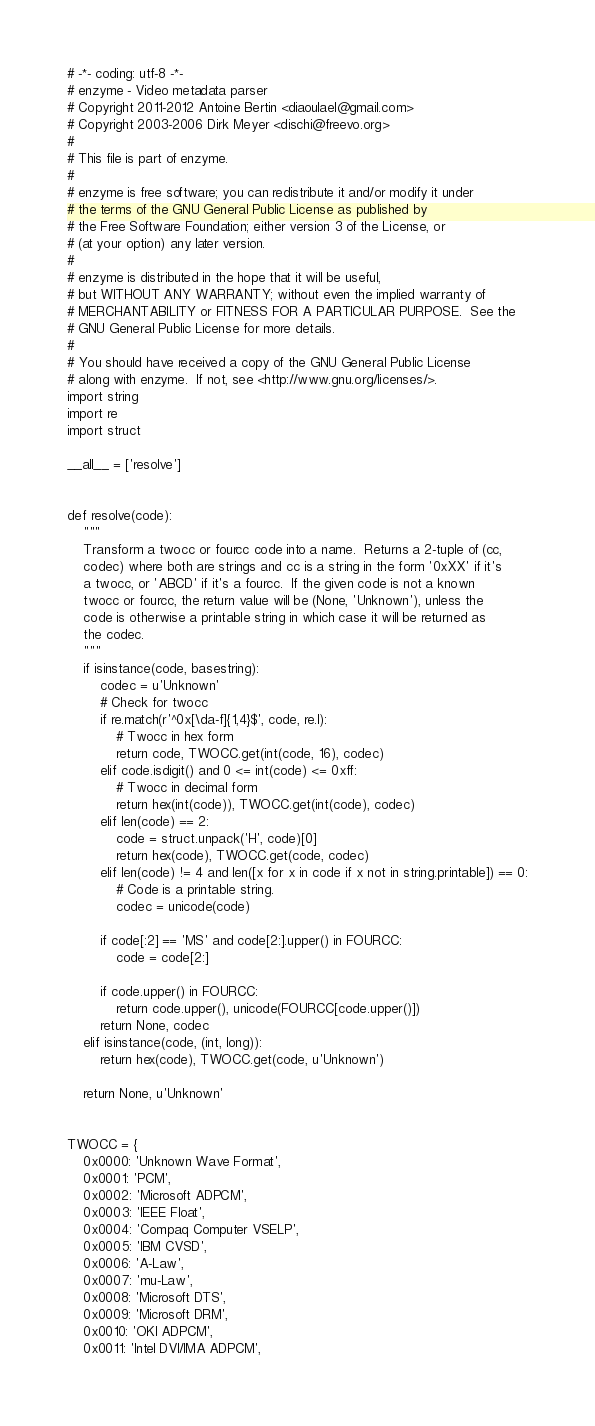<code> <loc_0><loc_0><loc_500><loc_500><_Python_># -*- coding: utf-8 -*-
# enzyme - Video metadata parser
# Copyright 2011-2012 Antoine Bertin <diaoulael@gmail.com>
# Copyright 2003-2006 Dirk Meyer <dischi@freevo.org>
#
# This file is part of enzyme.
#
# enzyme is free software; you can redistribute it and/or modify it under
# the terms of the GNU General Public License as published by
# the Free Software Foundation; either version 3 of the License, or
# (at your option) any later version.
#
# enzyme is distributed in the hope that it will be useful,
# but WITHOUT ANY WARRANTY; without even the implied warranty of
# MERCHANTABILITY or FITNESS FOR A PARTICULAR PURPOSE.  See the
# GNU General Public License for more details.
#
# You should have received a copy of the GNU General Public License
# along with enzyme.  If not, see <http://www.gnu.org/licenses/>.
import string
import re
import struct

__all__ = ['resolve']


def resolve(code):
    """
    Transform a twocc or fourcc code into a name.  Returns a 2-tuple of (cc,
    codec) where both are strings and cc is a string in the form '0xXX' if it's
    a twocc, or 'ABCD' if it's a fourcc.  If the given code is not a known
    twocc or fourcc, the return value will be (None, 'Unknown'), unless the
    code is otherwise a printable string in which case it will be returned as
    the codec.
    """
    if isinstance(code, basestring):
        codec = u'Unknown'
        # Check for twocc
        if re.match(r'^0x[\da-f]{1,4}$', code, re.I):
            # Twocc in hex form
            return code, TWOCC.get(int(code, 16), codec)
        elif code.isdigit() and 0 <= int(code) <= 0xff:
            # Twocc in decimal form
            return hex(int(code)), TWOCC.get(int(code), codec)
        elif len(code) == 2:
            code = struct.unpack('H', code)[0]
            return hex(code), TWOCC.get(code, codec)
        elif len(code) != 4 and len([x for x in code if x not in string.printable]) == 0:
            # Code is a printable string.
            codec = unicode(code)

        if code[:2] == 'MS' and code[2:].upper() in FOURCC:
            code = code[2:]

        if code.upper() in FOURCC:
            return code.upper(), unicode(FOURCC[code.upper()])
        return None, codec
    elif isinstance(code, (int, long)):
        return hex(code), TWOCC.get(code, u'Unknown')

    return None, u'Unknown'


TWOCC = {
    0x0000: 'Unknown Wave Format',
    0x0001: 'PCM',
    0x0002: 'Microsoft ADPCM',
    0x0003: 'IEEE Float',
    0x0004: 'Compaq Computer VSELP',
    0x0005: 'IBM CVSD',
    0x0006: 'A-Law',
    0x0007: 'mu-Law',
    0x0008: 'Microsoft DTS',
    0x0009: 'Microsoft DRM',
    0x0010: 'OKI ADPCM',
    0x0011: 'Intel DVI/IMA ADPCM',</code> 